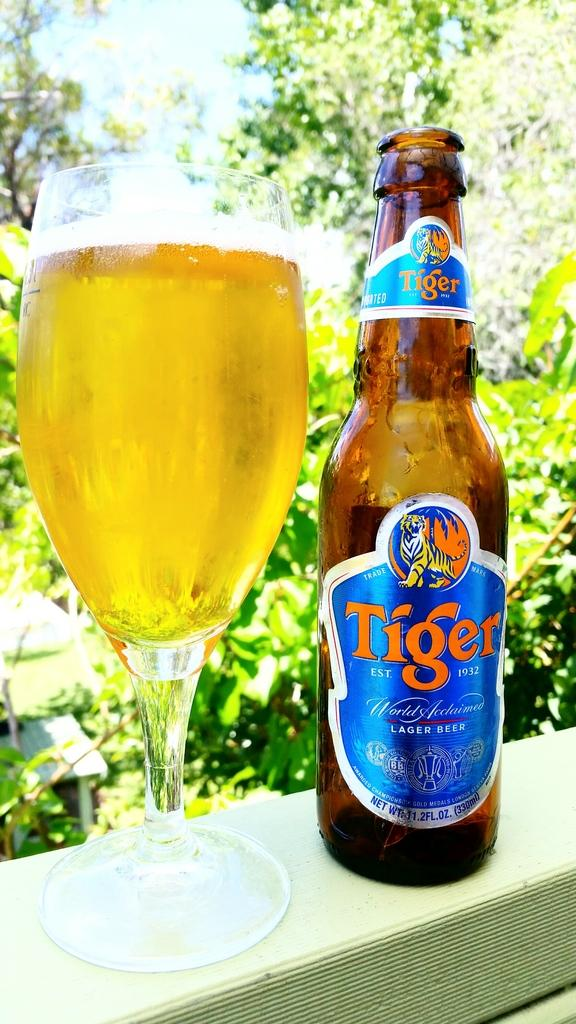<image>
Provide a brief description of the given image. A glass of Tiger Lager with an empty bottle sits on a ledge. 